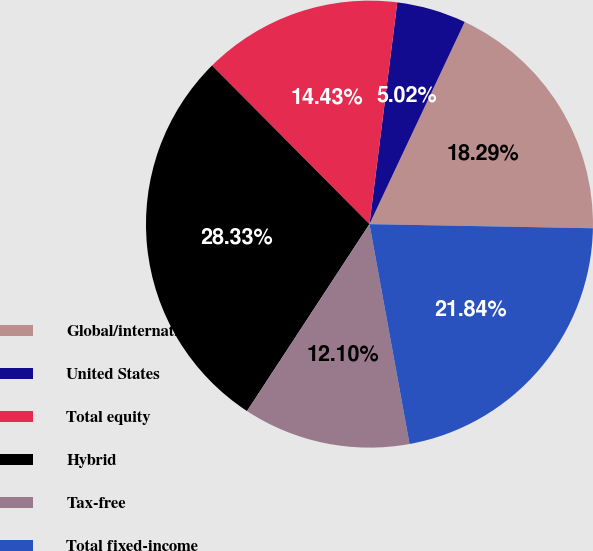<chart> <loc_0><loc_0><loc_500><loc_500><pie_chart><fcel>Global/international<fcel>United States<fcel>Total equity<fcel>Hybrid<fcel>Tax-free<fcel>Total fixed-income<nl><fcel>18.29%<fcel>5.02%<fcel>14.43%<fcel>28.33%<fcel>12.1%<fcel>21.84%<nl></chart> 